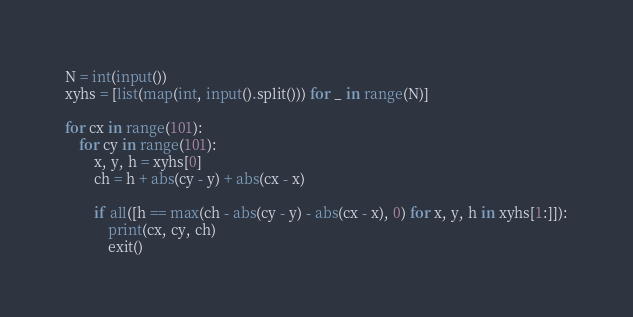Convert code to text. <code><loc_0><loc_0><loc_500><loc_500><_Python_>N = int(input())
xyhs = [list(map(int, input().split())) for _ in range(N)]

for cx in range(101):
    for cy in range(101):
        x, y, h = xyhs[0]
        ch = h + abs(cy - y) + abs(cx - x)
 
        if all([h == max(ch - abs(cy - y) - abs(cx - x), 0) for x, y, h in xyhs[1:]]):
            print(cx, cy, ch)
            exit()</code> 